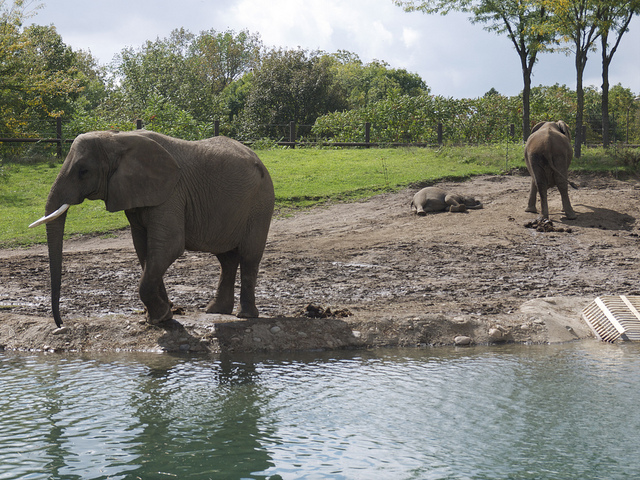Can you tell me about the habitat the elephants are in? Sure! The elephants are in an enclosure that simulates a savanna or grassland habitat, which is typical for African elephants in the wild. There's a pond for them to bathe in, and there are trees and open spaces, providing a comfortable outdoor environment for them. 